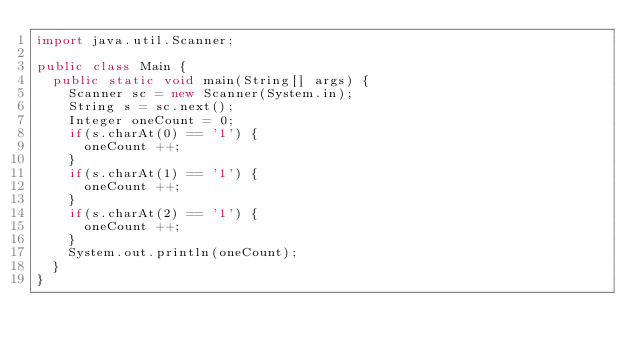Convert code to text. <code><loc_0><loc_0><loc_500><loc_500><_Java_>import java.util.Scanner;

public class Main {
	public static void main(String[] args) {
		Scanner sc = new Scanner(System.in);
		String s = sc.next();
		Integer oneCount = 0;
		if(s.charAt(0) == '1') {
			oneCount ++;
		}
		if(s.charAt(1) == '1') {
			oneCount ++;
		}
		if(s.charAt(2) == '1') {
			oneCount ++;
		}
		System.out.println(oneCount);
	}
}</code> 